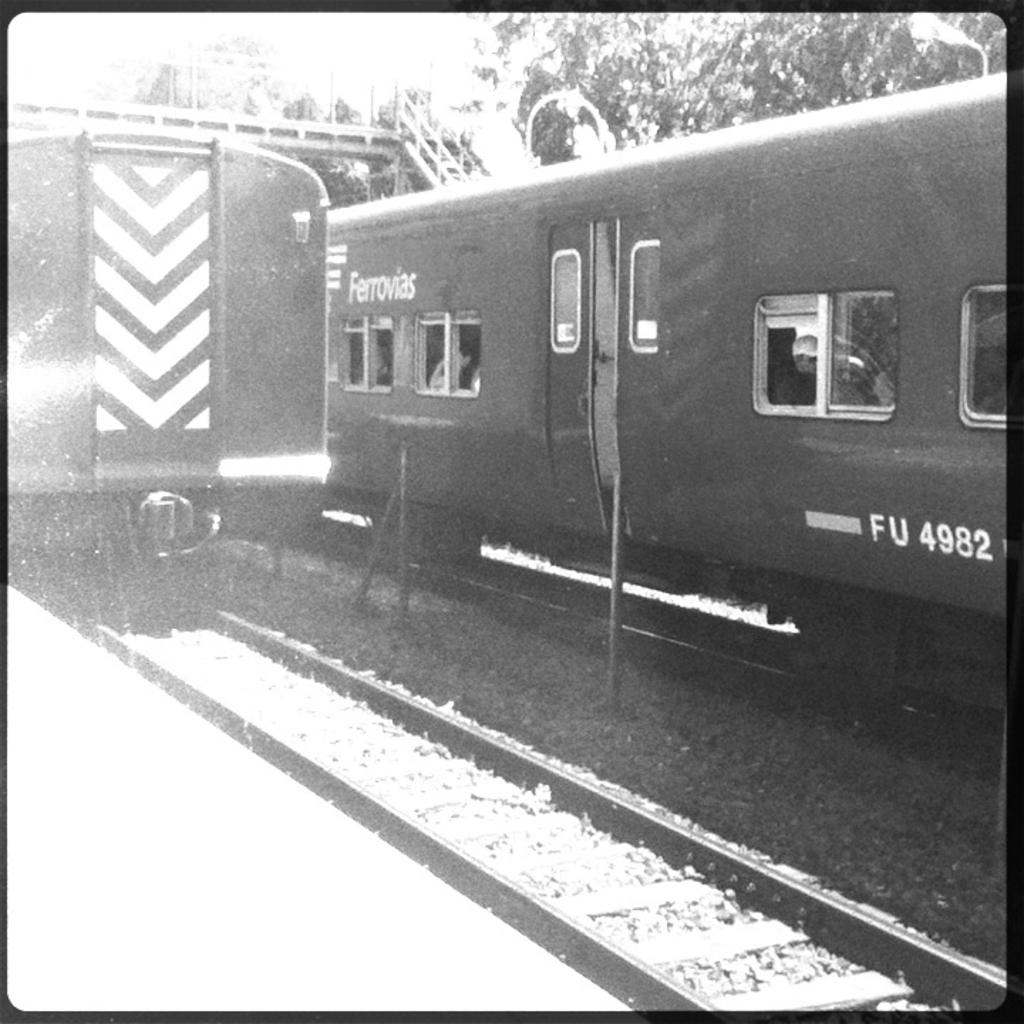What type of vehicles can be seen on the track in the image? There are trains on the track in the image. What structure is visible in the background of the image? There is a bridge visible in the background of the image. What type of vegetation can be seen in the background of the image? There are trees in the background of the image. What is the price of the sugar in the image? There is no sugar present in the image, so it is not possible to determine its price. 